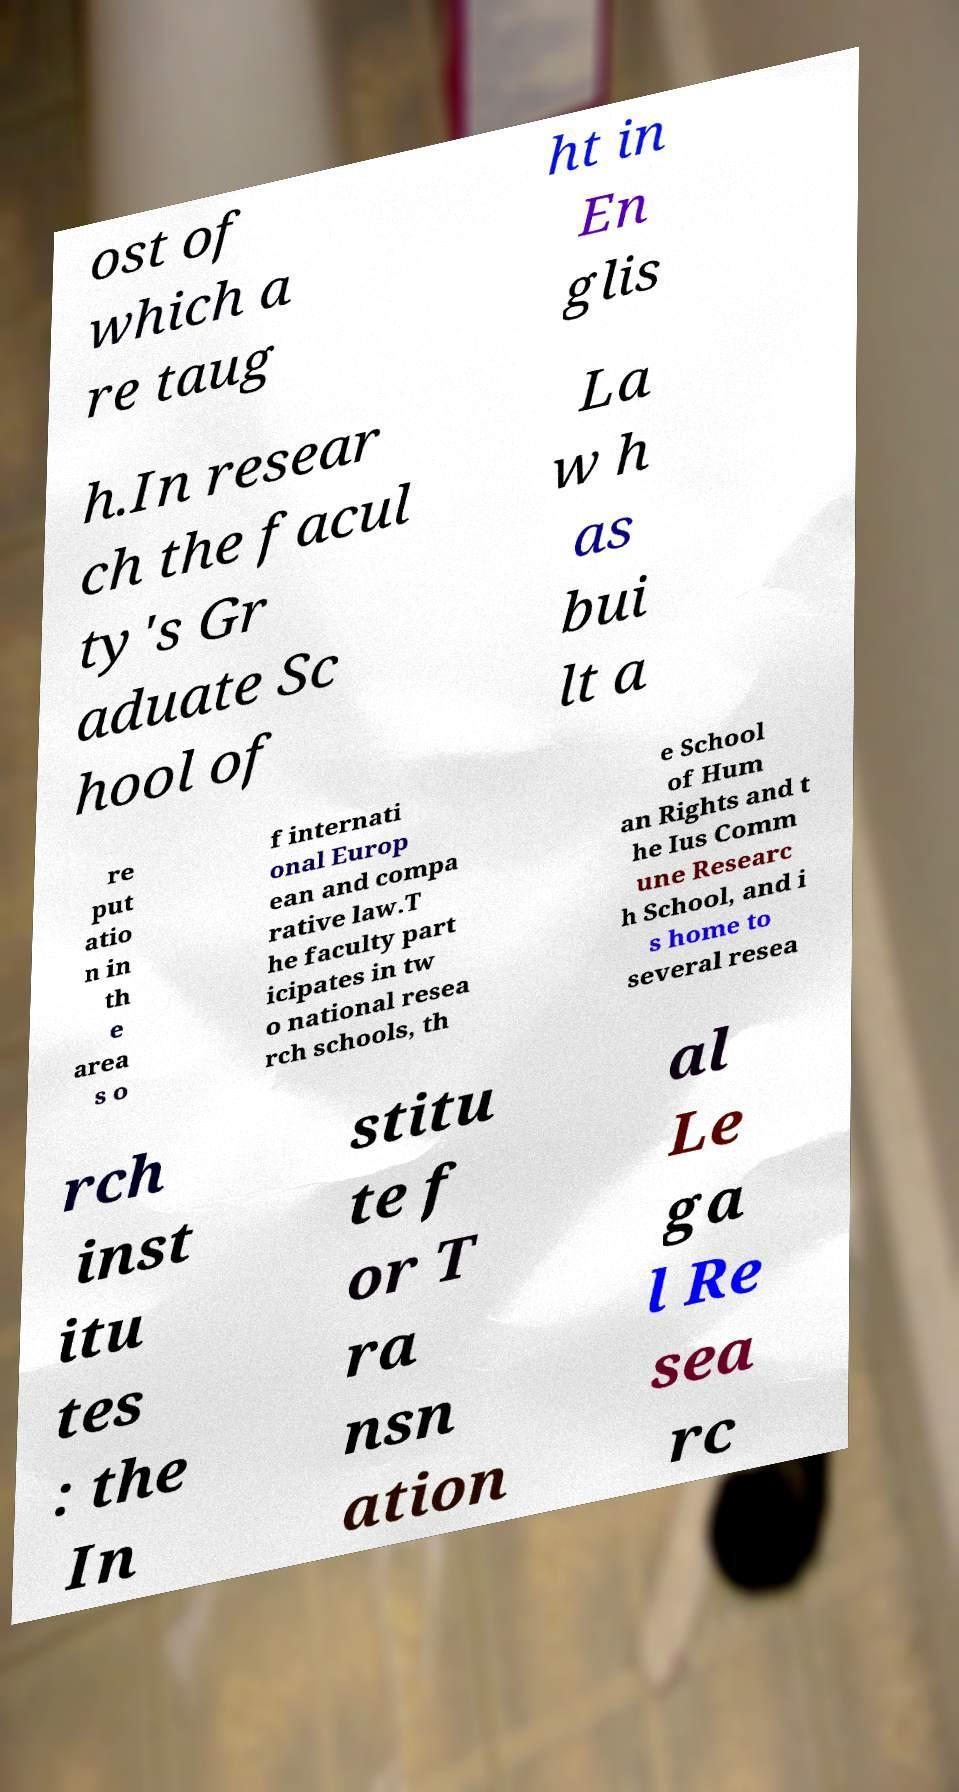There's text embedded in this image that I need extracted. Can you transcribe it verbatim? ost of which a re taug ht in En glis h.In resear ch the facul ty's Gr aduate Sc hool of La w h as bui lt a re put atio n in th e area s o f internati onal Europ ean and compa rative law.T he faculty part icipates in tw o national resea rch schools, th e School of Hum an Rights and t he Ius Comm une Researc h School, and i s home to several resea rch inst itu tes : the In stitu te f or T ra nsn ation al Le ga l Re sea rc 